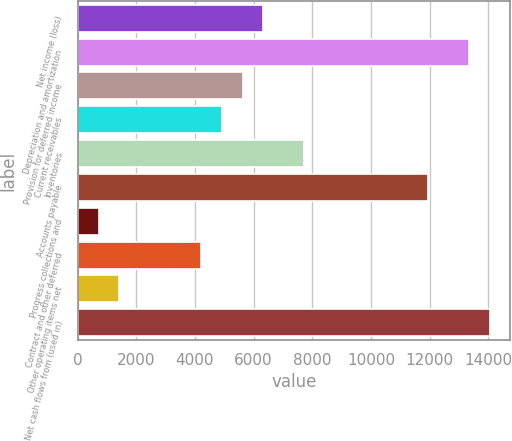Convert chart. <chart><loc_0><loc_0><loc_500><loc_500><bar_chart><fcel>Net income (loss)<fcel>Depreciation and amortization<fcel>Provision for deferred income<fcel>Current receivables<fcel>Inventories<fcel>Accounts payable<fcel>Progress collections and<fcel>Contract and other deferred<fcel>Other operating items net<fcel>Net cash flows from (used in)<nl><fcel>6327.7<fcel>13350.7<fcel>5625.4<fcel>4923.1<fcel>7732.3<fcel>11946.1<fcel>709.3<fcel>4220.8<fcel>1411.6<fcel>14053<nl></chart> 